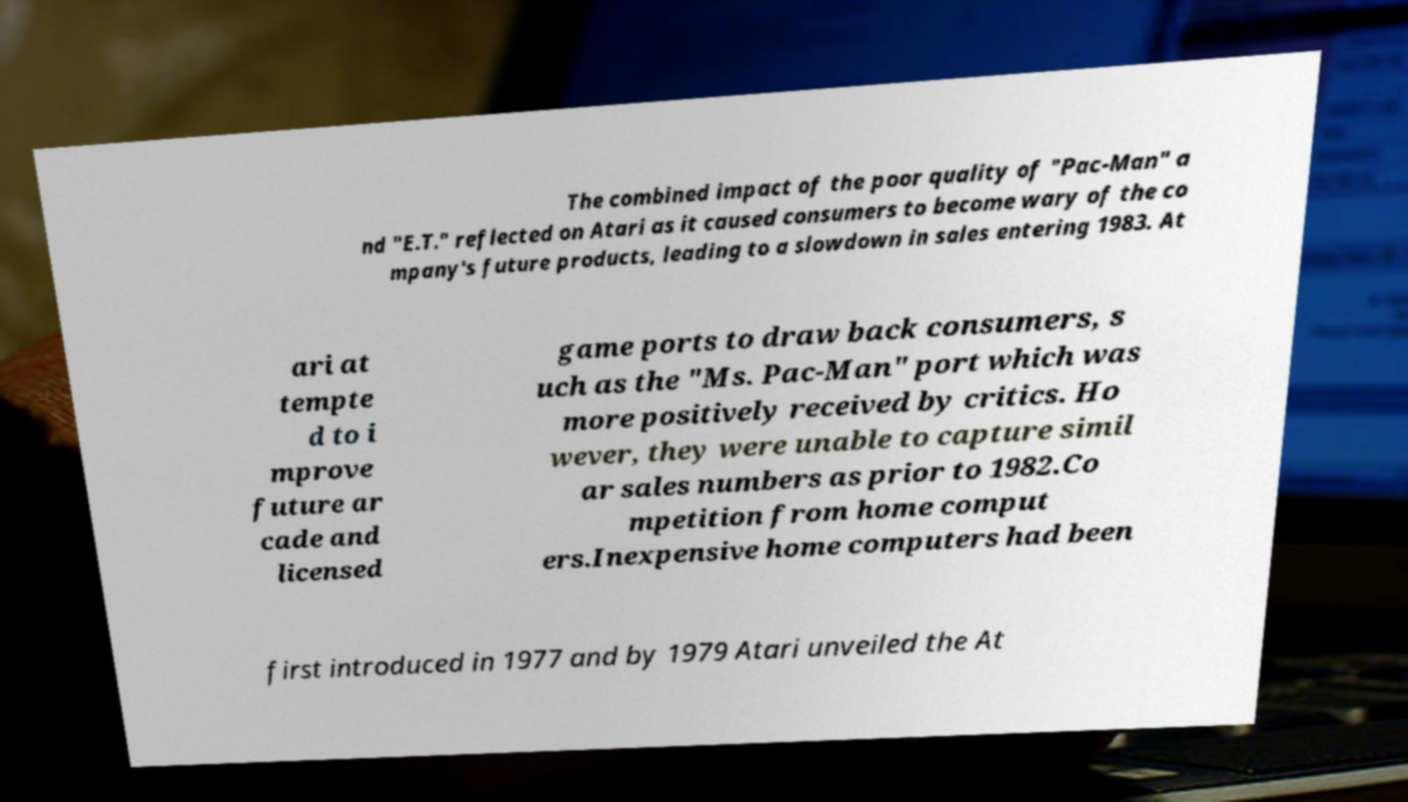Could you extract and type out the text from this image? The combined impact of the poor quality of "Pac-Man" a nd "E.T." reflected on Atari as it caused consumers to become wary of the co mpany's future products, leading to a slowdown in sales entering 1983. At ari at tempte d to i mprove future ar cade and licensed game ports to draw back consumers, s uch as the "Ms. Pac-Man" port which was more positively received by critics. Ho wever, they were unable to capture simil ar sales numbers as prior to 1982.Co mpetition from home comput ers.Inexpensive home computers had been first introduced in 1977 and by 1979 Atari unveiled the At 